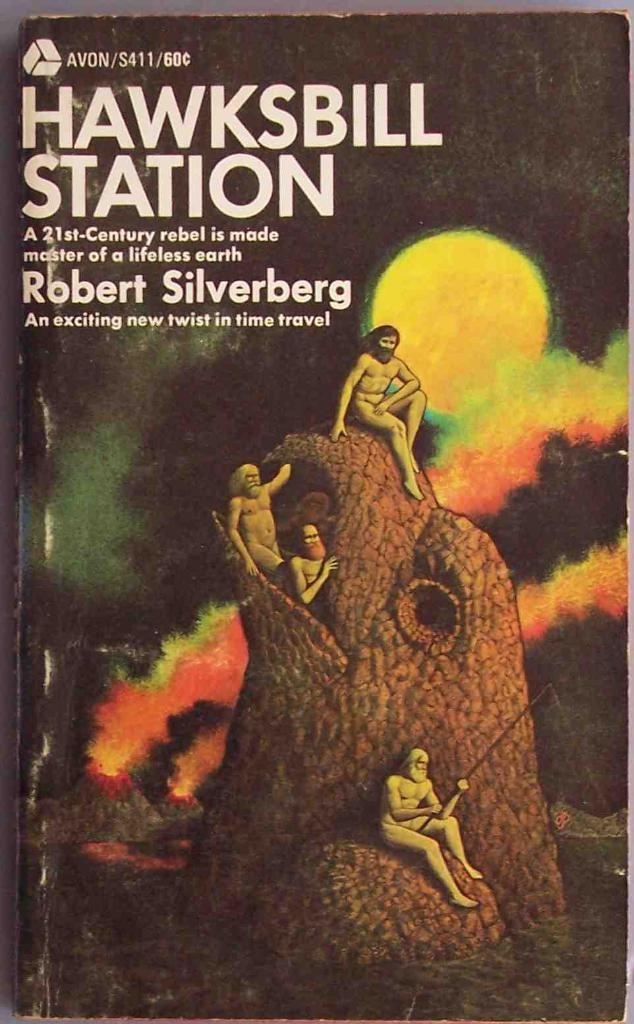<image>
Offer a succinct explanation of the picture presented. BOok cover showing people fishing named Hawksbill Station. 